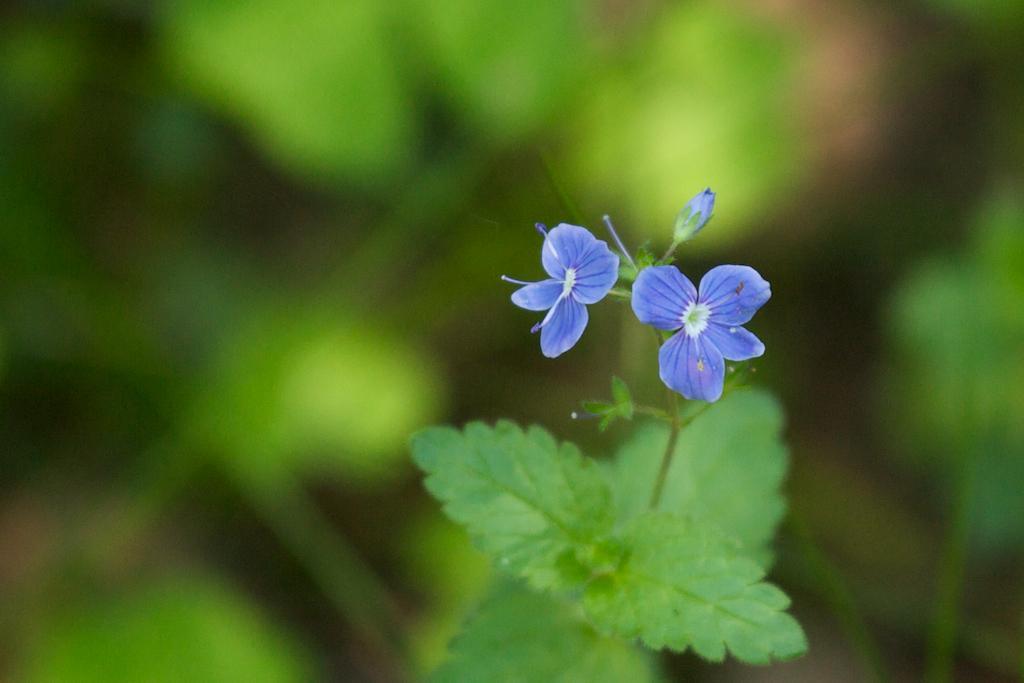In one or two sentences, can you explain what this image depicts? In this image I can see few flowers in white and purple color and I can see the plants in green color. 